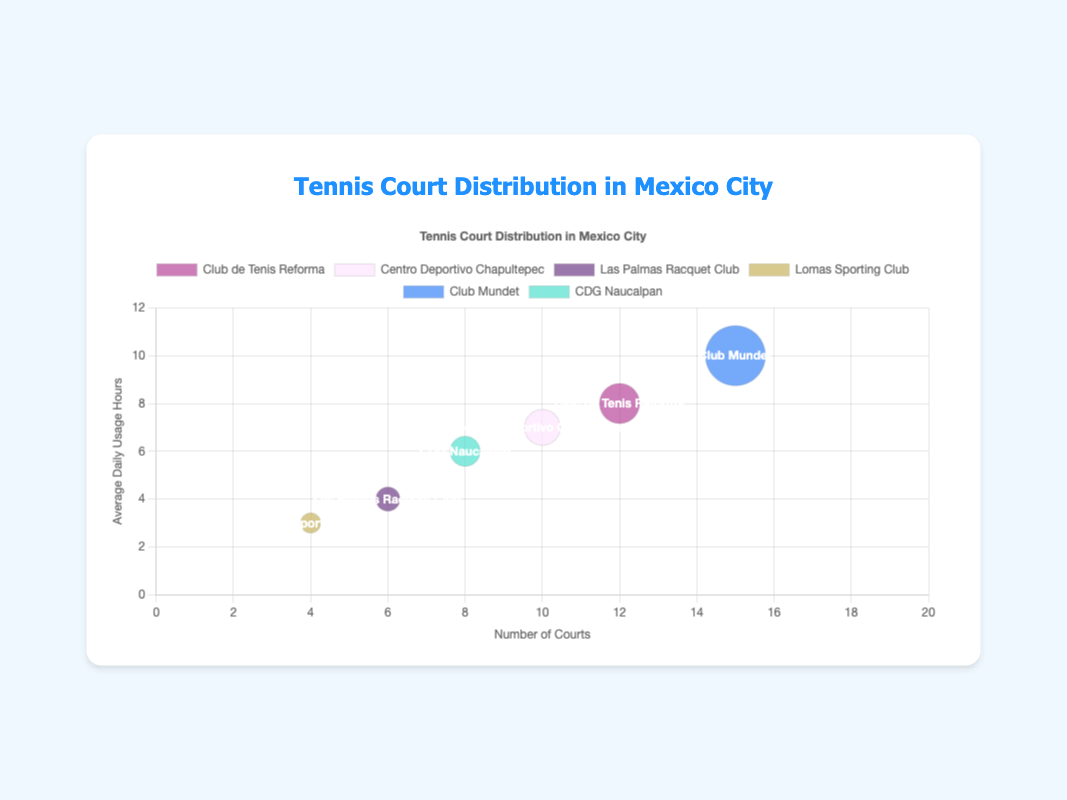Which tennis court has the highest number of courts? We look at the x-axis to find the data point with the highest x-value. Club Mundet has the highest number of courts with 15 courts.
Answer: Club Mundet How many total members are there at Club de Tenis Reforma? Club de Tenis Reforma has a bubble size that corresponds to its total member count. The radius of the bubble is 200/10 = 20.
Answer: 200 Which court type has the lowest average daily usage hours? We look at the y-axis to find the points with the lowest y-values. The Grass court at Lomas Sporting Club has an average daily usage of 3 hours, the lowest.
Answer: Grass (Lomas Sporting Club) What is the average daily usage hours for all Hard courts? We find the average daily usage hours for Club Mundet (10 hours) and CDG Naucalpan (6 hours) and average them: (10 + 6)/2 = 8 hours.
Answer: 8 Which court has the most total members? The size of the bubble relates to the total members. Club Mundet has the largest bubble, representing 300 members.
Answer: Club Mundet Compare the number of grass courts to clay courts. Which is more? Summing up the number of grass courts (6+4=10) and clay courts (12+10=22), we see that there are more clay courts.
Answer: Clay Which court has an 8-hour average daily usage and the largest number of courts among those? We find the data point that falls at (x: any, y: 8). Club de Tenis Reforma with 12 courts and 8 hours.
Answer: Club de Tenis Reforma How many total courts are there for grass and clay courts combined? Adding the courts for grass (6 + 4 = 10) and clay (12 + 10 = 22) results in 10 + 22 = 32.
Answer: 32 What is the average number of courts across all facilities? Sum the number of courts for all facilities and divide by the number of facilities: (12 + 10 + 6 + 4 + 15 + 8) / 6 = 55 / 6 ≈ 9.17 courts.
Answer: 9.17 Which tennis court facility has a higher average daily usage, Las Palmas Racquet Club or Lomas Sporting Club? Las Palmas Racquet Club has 4 hours, while Lomas Sporting Club has 3. Hence, Las Palmas Racquet Club has a higher average daily usage.
Answer: Las Palmas Racquet Club 